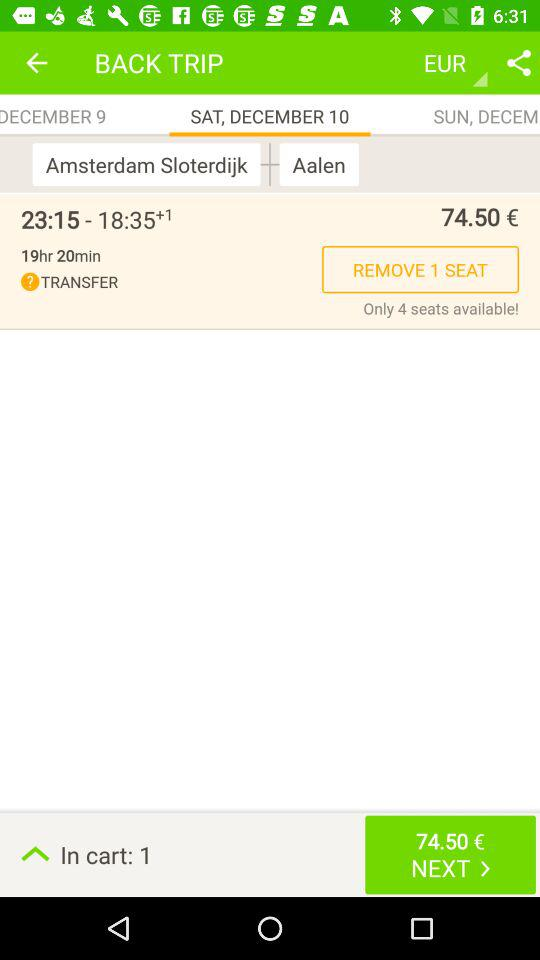What is the selected date? The selected date is Saturday, December 10. 